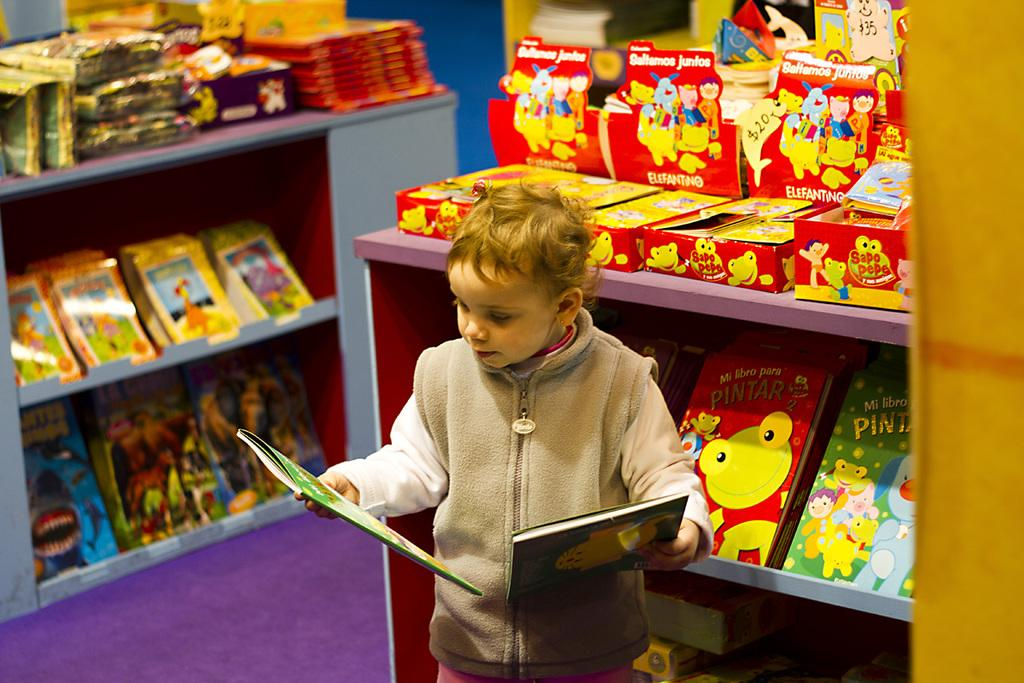<image>
Relay a brief, clear account of the picture shown. The book entitled "Mi Libro Para Pintar" is on the shelf behind the small boy looking at another book. 